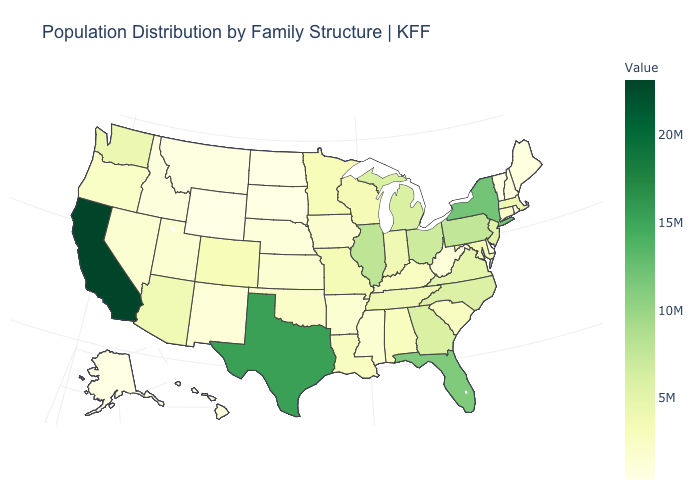Which states have the highest value in the USA?
Concise answer only. California. Does Virginia have the highest value in the USA?
Give a very brief answer. No. Does Virginia have a higher value than Idaho?
Keep it brief. Yes. Among the states that border Nebraska , which have the lowest value?
Write a very short answer. Wyoming. Does the map have missing data?
Quick response, please. No. Does Massachusetts have the highest value in the USA?
Quick response, please. No. 